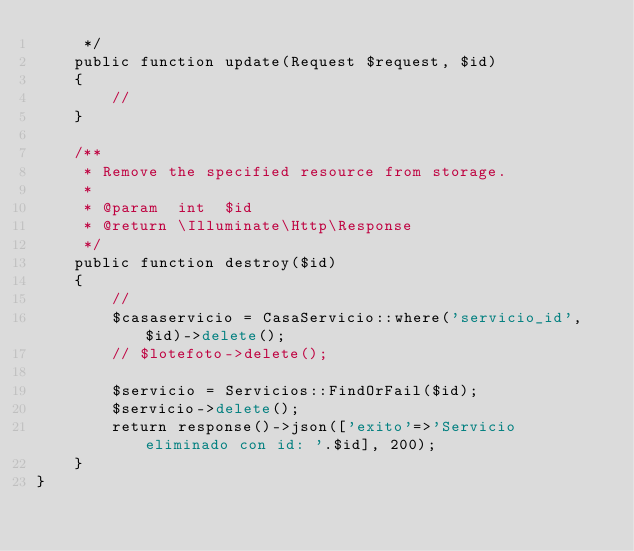<code> <loc_0><loc_0><loc_500><loc_500><_PHP_>     */
    public function update(Request $request, $id)
    {
        //
    }

    /**
     * Remove the specified resource from storage.
     *
     * @param  int  $id
     * @return \Illuminate\Http\Response
     */
    public function destroy($id)
    {
        //
        $casaservicio = CasaServicio::where('servicio_id', $id)->delete();
        // $lotefoto->delete();

        $servicio = Servicios::FindOrFail($id);
        $servicio->delete();
        return response()->json(['exito'=>'Servicio eliminado con id: '.$id], 200);
    }
}
</code> 